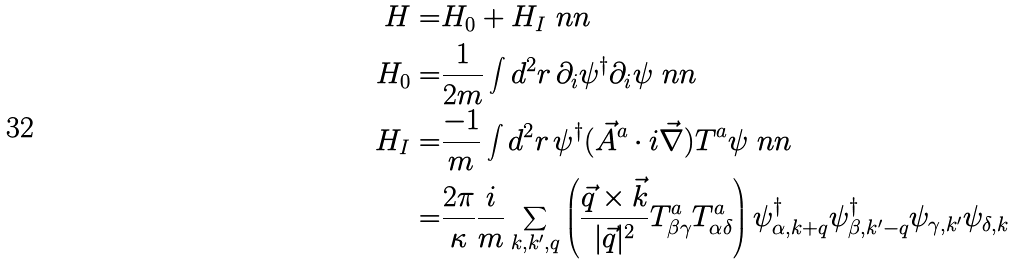<formula> <loc_0><loc_0><loc_500><loc_500>H = & H _ { 0 } + H _ { I } \ n n \\ H _ { 0 } = & \frac { 1 } { 2 m } \int d ^ { 2 } r \, \partial _ { i } \psi ^ { \dagger } \partial _ { i } \psi \ n n \\ H _ { I } = & \frac { - 1 } { m } \int d ^ { 2 } r \, \psi ^ { \dagger } ( \vec { A } ^ { a } \cdot i \vec { \nabla } ) T ^ { a } \psi \ n n \\ = & \frac { 2 \pi } { \kappa } \frac { i } { m } \sum _ { k , k ^ { \prime } , q } \left ( \frac { \vec { q } \times \vec { k } } { | \vec { q } | ^ { 2 } } T ^ { a } _ { \beta \gamma } T ^ { a } _ { \alpha \delta } \right ) \psi ^ { \dagger } _ { \alpha , k + q } \psi ^ { \dagger } _ { \beta , k ^ { \prime } - q } \psi _ { \gamma , k ^ { \prime } } \psi _ { \delta , k }</formula> 